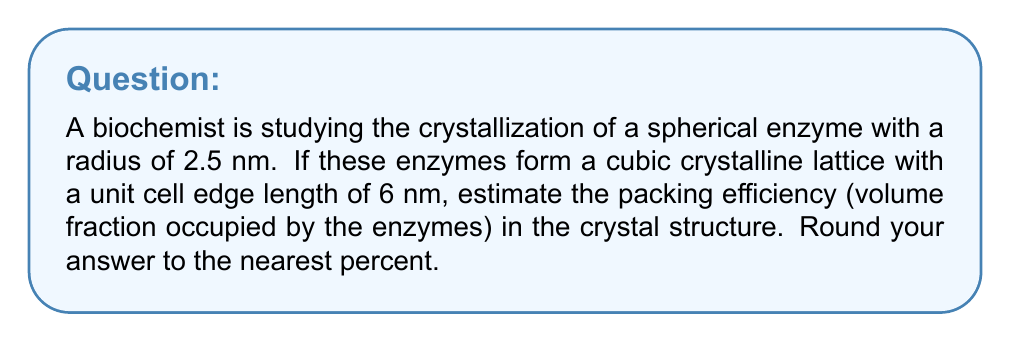Help me with this question. To estimate the packing efficiency, we need to follow these steps:

1. Calculate the volume of a single enzyme:
   $$V_{enzyme} = \frac{4}{3}\pi r^3 = \frac{4}{3}\pi (2.5 \text{ nm})^3 = 65.45 \text{ nm}^3$$

2. Calculate the volume of the unit cell:
   $$V_{cell} = a^3 = (6 \text{ nm})^3 = 216 \text{ nm}^3$$

3. Determine the number of enzymes per unit cell:
   In a simple cubic lattice, there is one enzyme per unit cell.

4. Calculate the total volume occupied by enzymes in one unit cell:
   $$V_{total\ enzymes} = 1 \times V_{enzyme} = 65.45 \text{ nm}^3$$

5. Calculate the packing efficiency (volume fraction):
   $$\text{Packing Efficiency} = \frac{V_{total\ enzymes}}{V_{cell}} \times 100\%$$
   $$= \frac{65.45 \text{ nm}^3}{216 \text{ nm}^3} \times 100\% = 30.30\%$$

6. Round to the nearest percent:
   30.30% rounds to 30%

This packing efficiency is relatively low compared to more efficient packing arrangements like face-centered cubic (74%) or body-centered cubic (68%), which is common for proteins in crystal structures. The simple cubic arrangement leaves significant void space between the enzymes.
Answer: 30% 